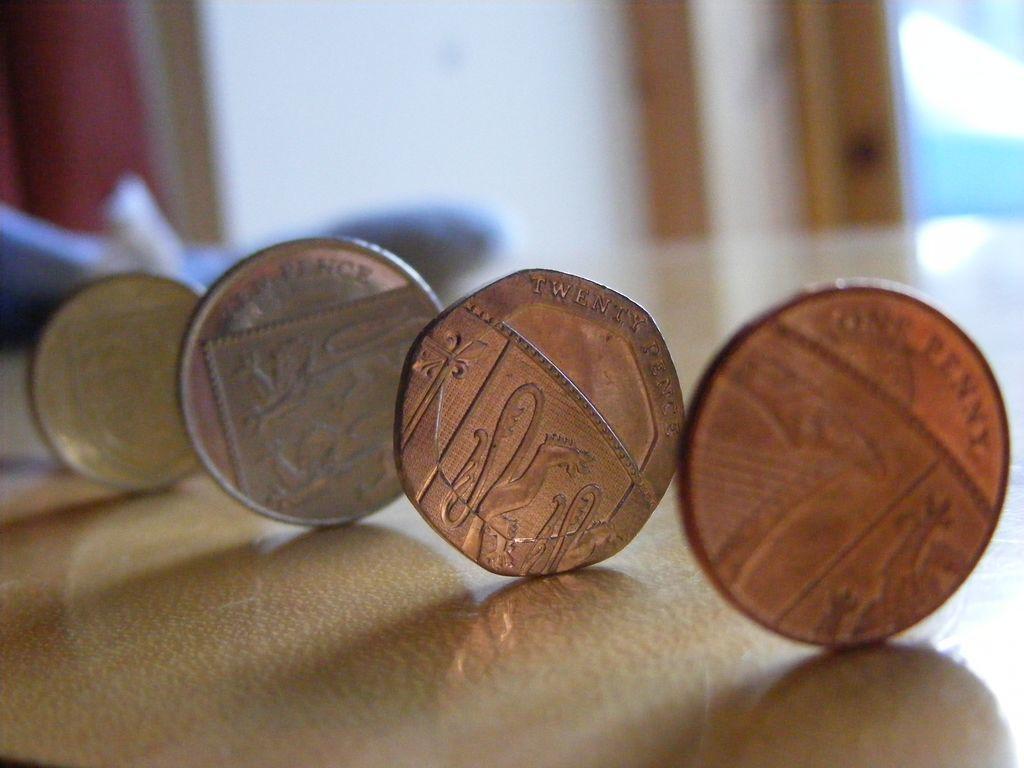How much is the second coin from the right worth?
Ensure brevity in your answer.  Twenty pence. 